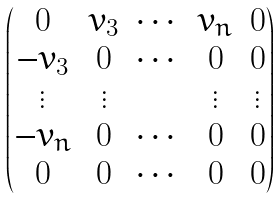<formula> <loc_0><loc_0><loc_500><loc_500>\begin{pmatrix} 0 & v _ { 3 } & \cdots & v _ { n } & 0 \\ - v _ { 3 } & 0 & \cdots & 0 & 0 \\ \vdots & \vdots & & \vdots & \vdots \\ - v _ { n } & 0 & \cdots & 0 & 0 \\ 0 & 0 & \cdots & 0 & 0 \end{pmatrix}</formula> 